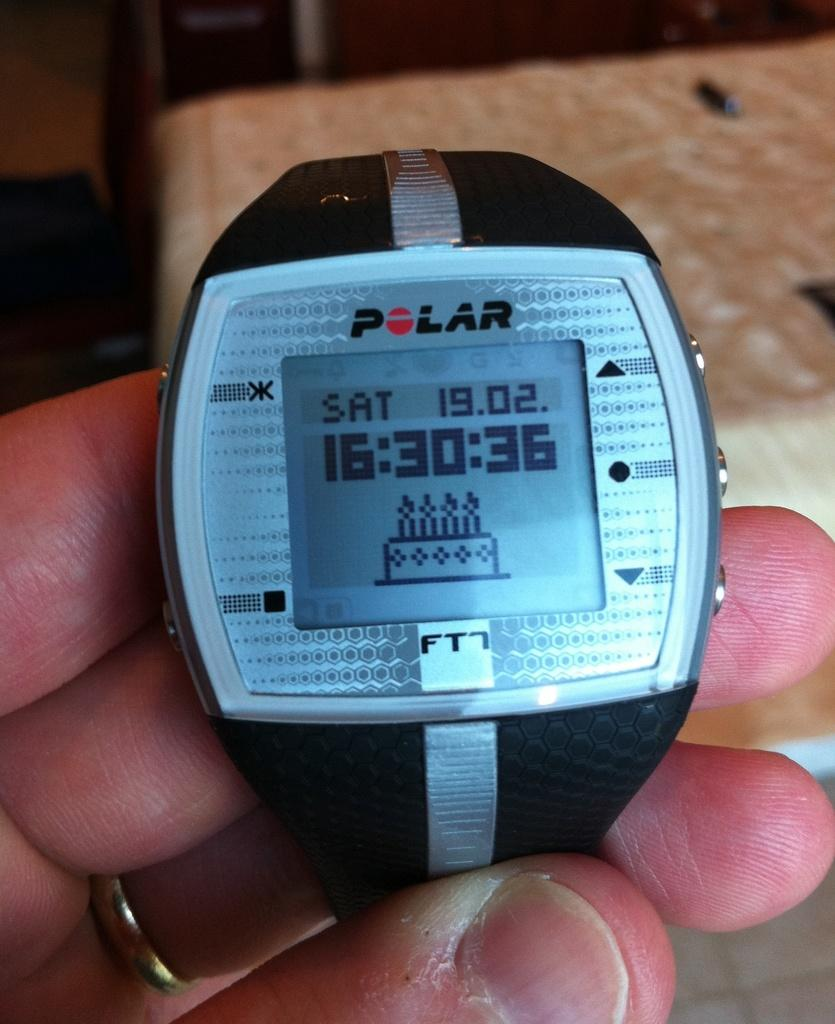<image>
Give a short and clear explanation of the subsequent image. February 2nd, 16:30 is being shown on this Polar watch. 